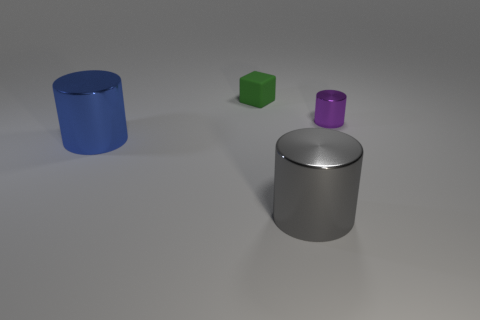Subtract all large cylinders. How many cylinders are left? 1 Add 4 small green rubber cubes. How many objects exist? 8 Subtract all gray cylinders. How many cylinders are left? 2 Subtract 2 cylinders. How many cylinders are left? 1 Subtract all blocks. How many objects are left? 3 Subtract all small purple things. Subtract all large gray metal objects. How many objects are left? 2 Add 3 rubber things. How many rubber things are left? 4 Add 4 purple metallic cylinders. How many purple metallic cylinders exist? 5 Subtract 1 green blocks. How many objects are left? 3 Subtract all purple cylinders. Subtract all blue cubes. How many cylinders are left? 2 